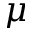Convert formula to latex. <formula><loc_0><loc_0><loc_500><loc_500>\mu</formula> 